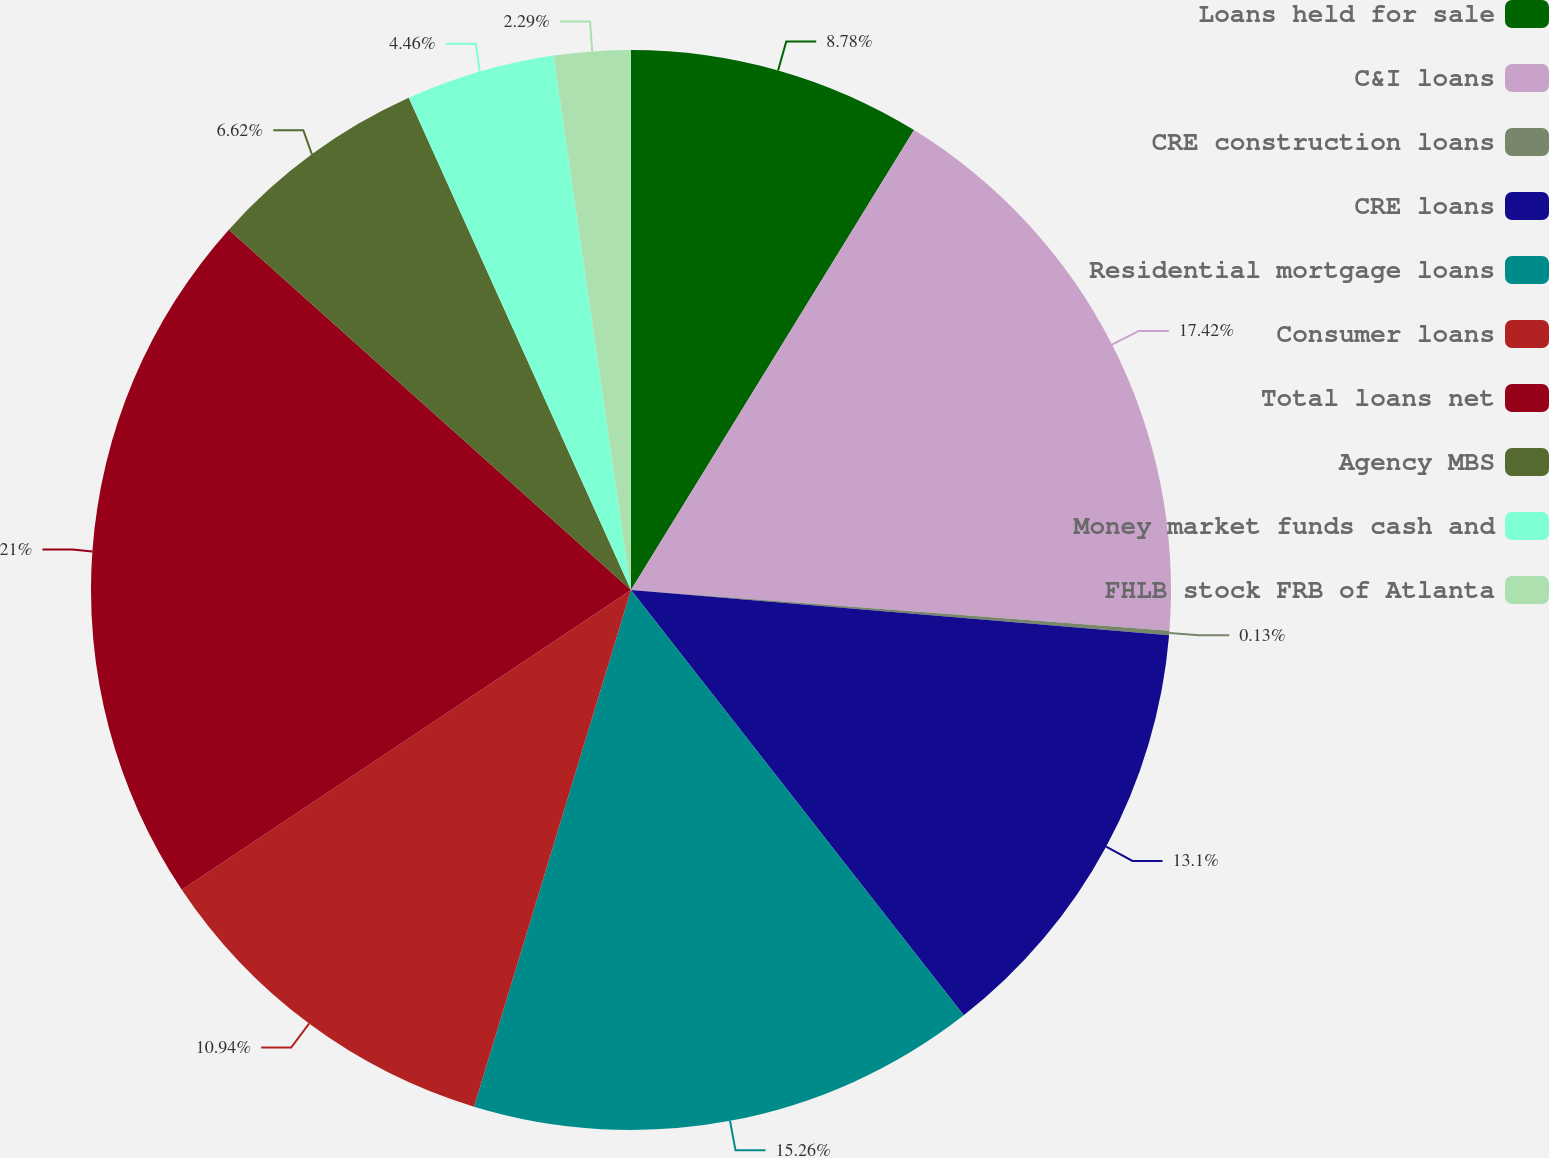<chart> <loc_0><loc_0><loc_500><loc_500><pie_chart><fcel>Loans held for sale<fcel>C&I loans<fcel>CRE construction loans<fcel>CRE loans<fcel>Residential mortgage loans<fcel>Consumer loans<fcel>Total loans net<fcel>Agency MBS<fcel>Money market funds cash and<fcel>FHLB stock FRB of Atlanta<nl><fcel>8.78%<fcel>17.42%<fcel>0.13%<fcel>13.1%<fcel>15.26%<fcel>10.94%<fcel>20.99%<fcel>6.62%<fcel>4.46%<fcel>2.29%<nl></chart> 